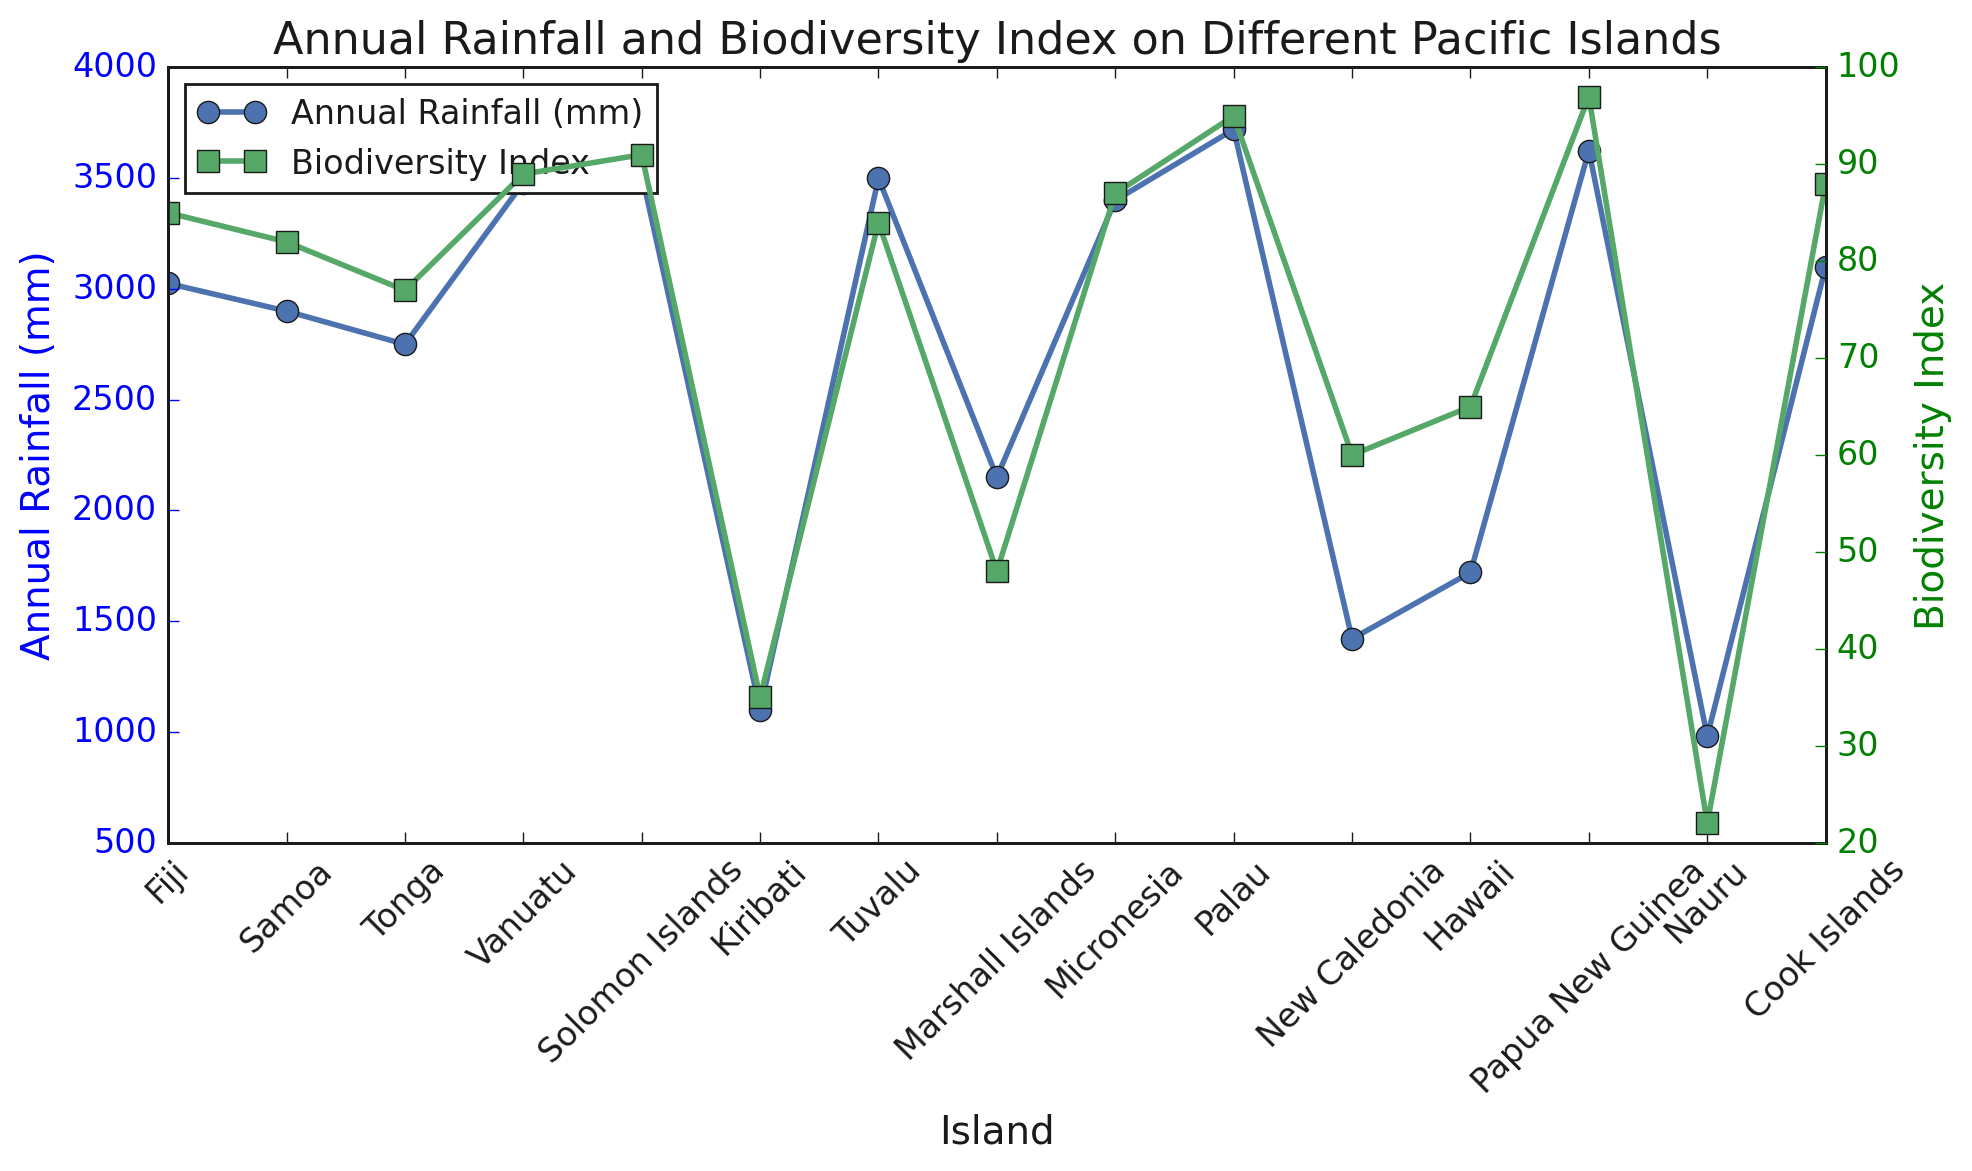Which island has the highest biodiversity index? To find the highest biodiversity index, look at the green line in the chart and identify the peak point. Palau has the highest biodiversity index.
Answer: Palau What is the difference in annual rainfall between Kiribati and the Solomon Islands? Find the annual rainfall for both Kiribati and the Solomon Islands from the blue line in the chart. Kiribati has 1100 mm and the Solomon Islands have 3520 mm. The difference is 3520 - 1100 = 2420 mm.
Answer: 2420 mm Which islands have a biodiversity index greater than 90? Look at the green line to identify the islands with a biodiversity index above 90. Papua New Guinea (97) and Solomon Islands (91) meet this criterion.
Answer: Papua New Guinea and Solomon Islands Which island has the least annual rainfall, and what is its biodiversity index? To find the island with the least rainfall, look for the lowest point on the blue line. Nauru has the least annual rainfall (980 mm). Its biodiversity index can be found from the green line directly above Nauru, which is 22.
Answer: Nauru, 22 What is the average biodiversity index of islands with more than 3000 mm of annual rainfall? Identify the islands with more than 3000 mm of rainfall (Fiji, Vanuatu, Solomon Islands, Tuvalu, Micronesia, Palau, Papua New Guinea, Cook Islands). Sum their biodiversity indices (85 + 89 + 91 + 84 + 87 + 95 + 97 + 88 = 716). There are 8 islands, so the average is 716 / 8 = 89.5.
Answer: 89.5 How does the biodiversity index of Marshall Islands compare to that of New Caledonia? Check the green line for both Marshall Islands (48) and New Caledonia (60). Marshall Islands has a lower biodiversity index compared to New Caledonia.
Answer: Lower By how much does the biodiversity index of Fiji exceed that of Hawaii? Fiji has a biodiversity index of 85 and Hawaii has 65. The difference is 85 - 65 = 20.
Answer: 20 Which island has the highest annual rainfall, and what is its biodiversity index? The highest annual rainfall is represented by the highest point on the blue line. Papua New Guinea has the highest rainfall (3625 mm). Its biodiversity index, found on the green line, is 97.
Answer: Papua New Guinea, 97 Are there any islands with both their annual rainfall and biodiversity index below the average values? Calculate the average annual rainfall and biodiversity index across all islands. Average rainfall = (total rainfall / number of islands). Total rainfall = 40710 mm, number of islands = 15, so average = 2714 mm. Average biodiversity index = (total biodiversity / number of islands). Total biodiversity = 1011, number of islands = 15, so average = 67.4. The islands below both these averages are Nauru (980 mm, 22) and Kiribati (1100 mm, 35).
Answer: Nauru and Kiribati Which island has the closest biodiversity index to 70? Look at the green line to find the island whose biodiversity index is closest to 70. Hawaii has a biodiversity index of 65, which is the closest to 70.
Answer: Hawaii 